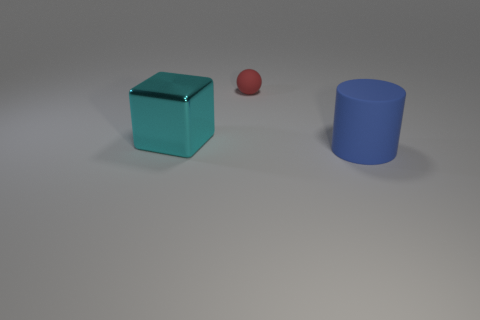How many other objects are the same material as the big blue object?
Provide a succinct answer. 1. What number of things are either matte objects right of the small matte thing or things that are behind the large blue cylinder?
Ensure brevity in your answer.  3. Is there a red matte cube?
Your answer should be very brief. No. What is the size of the object that is in front of the tiny red rubber sphere and behind the blue rubber cylinder?
Offer a terse response. Large. The tiny rubber object is what shape?
Ensure brevity in your answer.  Sphere. There is a rubber object behind the big cylinder; is there a small red rubber sphere that is in front of it?
Give a very brief answer. No. What material is the thing that is the same size as the blue matte cylinder?
Provide a succinct answer. Metal. Are there any matte cylinders that have the same size as the sphere?
Provide a succinct answer. No. What is the material of the large thing that is to the left of the rubber cylinder?
Ensure brevity in your answer.  Metal. Is the material of the thing behind the cyan metal object the same as the cylinder?
Your answer should be very brief. Yes. 